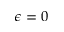<formula> <loc_0><loc_0><loc_500><loc_500>\epsilon = 0</formula> 